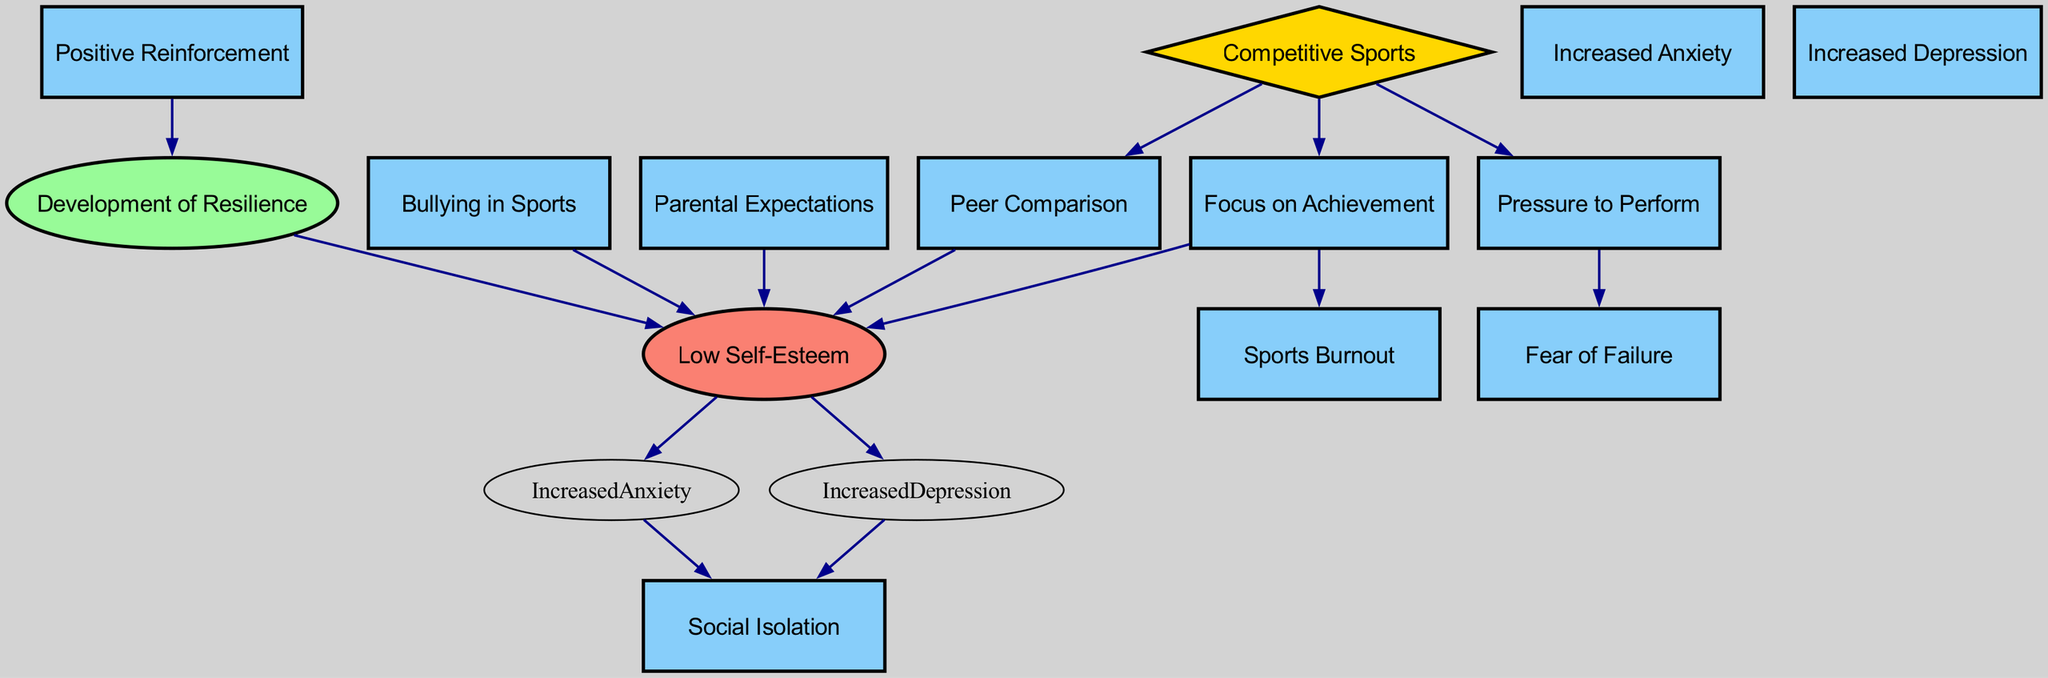What are the total number of nodes in the diagram? The diagram consists of several nodes that represent different concepts related to competitive sports and their impact on self-esteem. By counting each unique node listed, we find that there are 13 nodes in total.
Answer: 13 Which node is identified as the main source in the diagram? The main source in the diagram, which represents the overarching concept from which other nodes and influences stem, is labeled "Competitive Sports." By examining the edges, it's clear that other concepts branch from this node.
Answer: Competitive Sports How many different types of negative social impacts are noted in the diagram? The diagram shows various negative social impacts connected to "Low Self-Esteem," specifically "Increased Anxiety" and "Increased Depression," both leading to "Social Isolation." Therefore, there are two distinct types of negative social impacts highlighted.
Answer: 2 What is the relationship between "Achievement Focus" and "Burnout"? The diagram indicates a direct connection (edge) from "Achievement Focus" to "Burnout," suggesting that a strong emphasis on achievements in sports can lead to feelings of burnout in youth athletes.
Answer: Direct connection Which node is affected by both "Parental Expectations" and "Bullying"? "Low Self-Esteem" is the node that is influenced by both "Parental Expectations" and "Bullying" as per the directed edges, showing these are factors that contribute to a decrease in self-worth among youth athletes.
Answer: Low Self-Esteem How does "Positive Reinforcement" relate to "Resilience"? The directed graph indicates that "Positive Reinforcement" leads to the development of "Resilience." This shows a constructive relationship where positive feedback helps youth athletes build resilience against the pressures of competitive sports.
Answer: Development of Resilience What can be inferred about "Low Self-Esteem" in terms of its consequences? The diagram outlines that "Low Self-Esteem" is a precursor to various negative outcomes, specifically "Increased Anxiety" and "Increased Depression," both of which lead to "Social Isolation." Thus, it can be inferred that low self-esteem is a significant risk factor for these mental health issues.
Answer: Increased Anxiety, Increased Depression, Social Isolation Identify the node that has the most edges leading from it. By examining the connections, "Low Self-Esteem" has multiple outgoing edges pointing to "Increased Anxiety," "Increased Depression," and also connects to "Resilience." This indicates that it has significant implications in the context of the graph.
Answer: Low Self-Esteem 